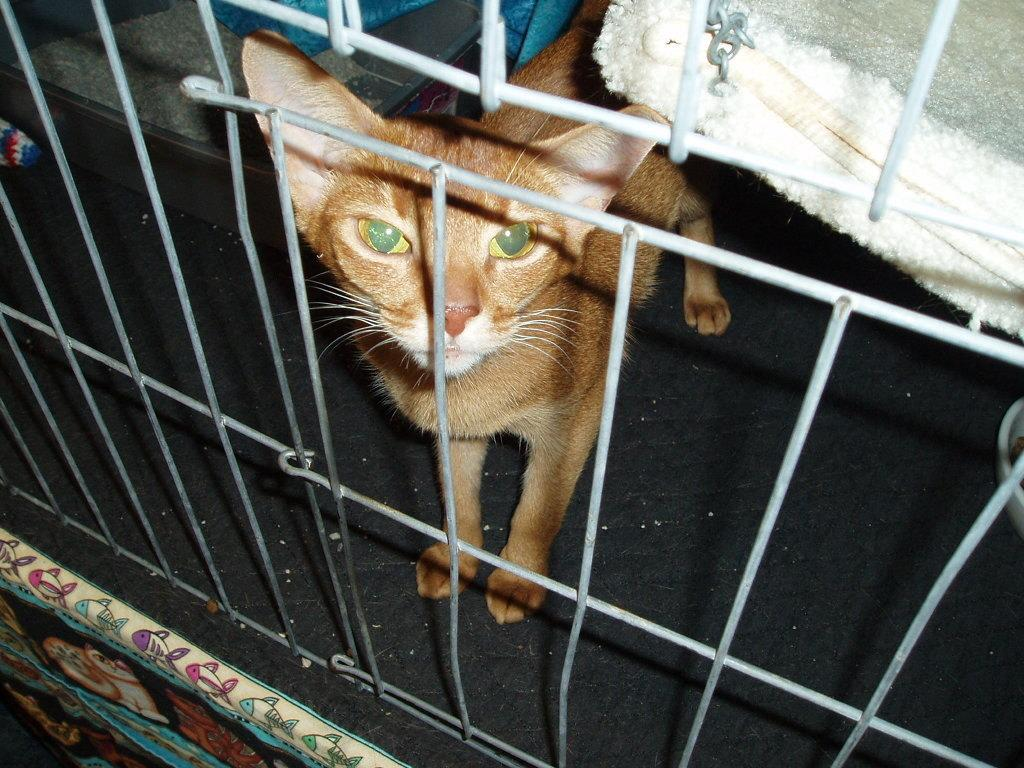What type of animal is in the image? There is a cat in the image. Where is the cat positioned in the image? The cat is standing on the floor. What else can be seen in the image besides the cat? There is a mesh in the image. How many lizards are crawling on the rose in the image? There are no lizards or roses present in the image; it features a cat standing on the floor and a mesh. 